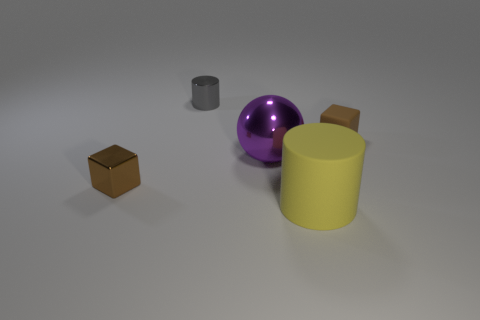Add 2 large purple blocks. How many objects exist? 7 Add 5 blue spheres. How many blue spheres exist? 5 Subtract 1 brown blocks. How many objects are left? 4 Subtract all balls. How many objects are left? 4 Subtract all small brown metal cubes. Subtract all big rubber objects. How many objects are left? 3 Add 3 small shiny objects. How many small shiny objects are left? 5 